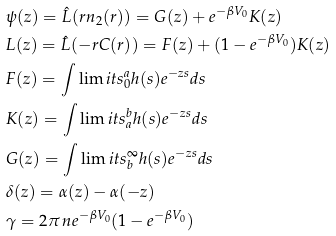Convert formula to latex. <formula><loc_0><loc_0><loc_500><loc_500>& \psi ( z ) = \hat { L } ( r n _ { 2 } ( r ) ) = G ( z ) + e ^ { - \beta V _ { 0 } } K ( z ) \\ & L ( z ) = \hat { L } ( - r C ( r ) ) = F ( z ) + ( 1 - e ^ { - \beta V _ { 0 } } ) K ( z ) \\ & F ( z ) = \int \lim i t s ^ { a } _ { 0 } h ( s ) e ^ { - z s } d s \\ & K ( z ) = \int \lim i t s ^ { b } _ { a } h ( s ) e ^ { - z s } d s \\ & G ( z ) = \int \lim i t s ^ { \infty } _ { b } h ( s ) e ^ { - z s } d s \\ & \delta ( z ) = \alpha ( z ) - \alpha ( - z ) \\ & \gamma = 2 \pi \, n e ^ { - \beta V _ { 0 } } ( 1 - e ^ { - \beta V _ { 0 } } )</formula> 